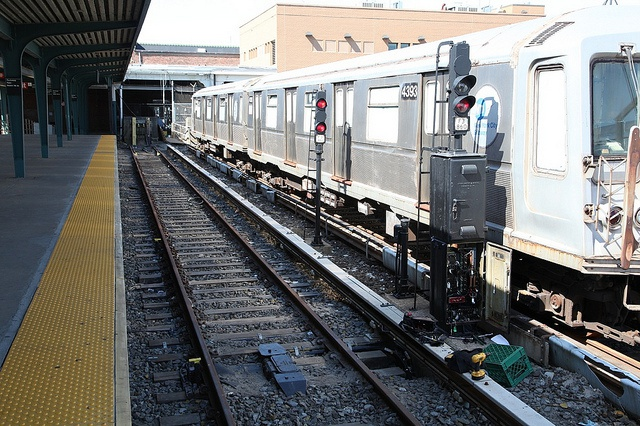Describe the objects in this image and their specific colors. I can see train in black, white, darkgray, and gray tones, traffic light in black, gray, darkgray, and lightgray tones, and traffic light in black, gray, white, and darkgray tones in this image. 